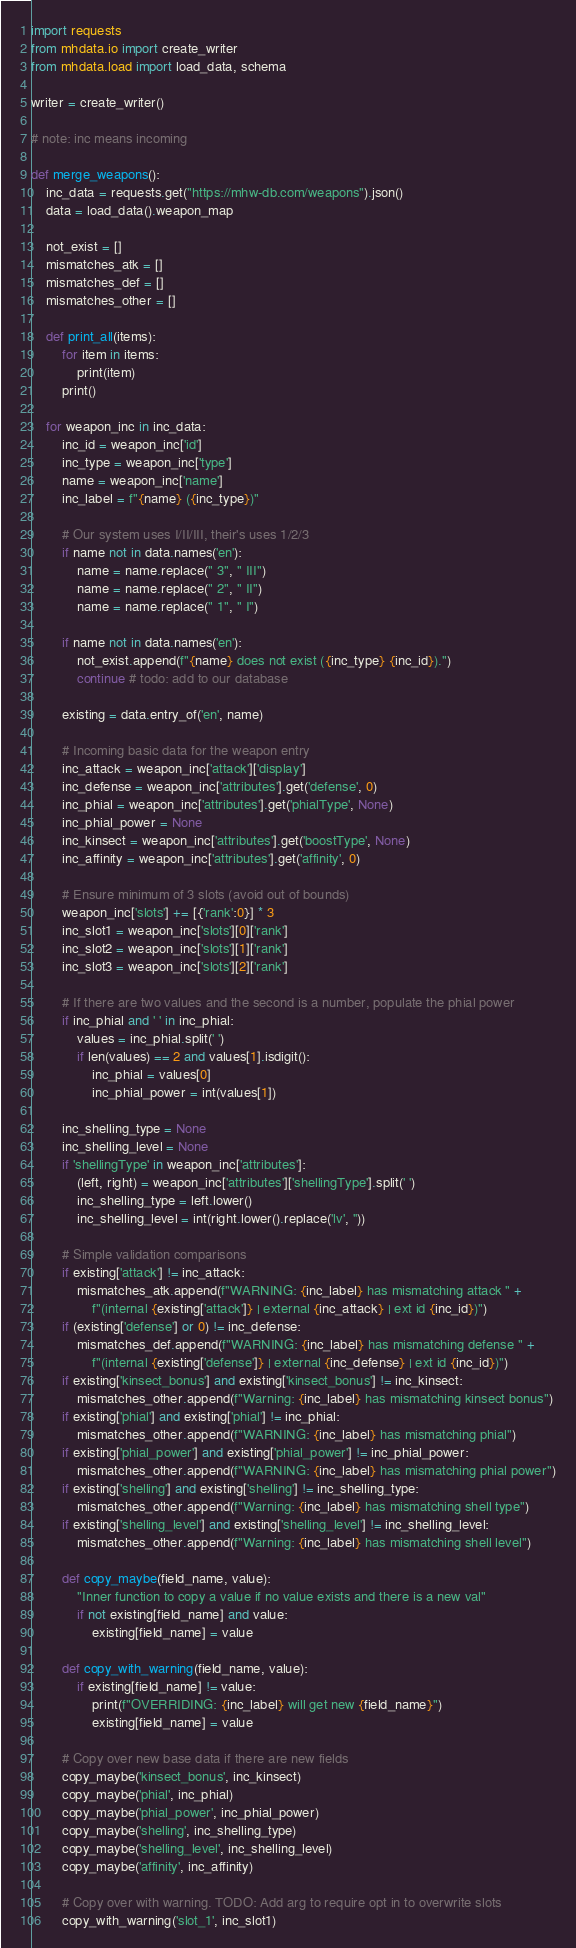Convert code to text. <code><loc_0><loc_0><loc_500><loc_500><_Python_>import requests
from mhdata.io import create_writer
from mhdata.load import load_data, schema

writer = create_writer()

# note: inc means incoming

def merge_weapons():
    inc_data = requests.get("https://mhw-db.com/weapons").json()
    data = load_data().weapon_map

    not_exist = []
    mismatches_atk = []
    mismatches_def = []
    mismatches_other = []

    def print_all(items):
        for item in items:
            print(item)
        print()

    for weapon_inc in inc_data:
        inc_id = weapon_inc['id']
        inc_type = weapon_inc['type']
        name = weapon_inc['name']
        inc_label = f"{name} ({inc_type})"

        # Our system uses I/II/III, their's uses 1/2/3
        if name not in data.names('en'):
            name = name.replace(" 3", " III")
            name = name.replace(" 2", " II")
            name = name.replace(" 1", " I")

        if name not in data.names('en'):
            not_exist.append(f"{name} does not exist ({inc_type} {inc_id}).")
            continue # todo: add to our database

        existing = data.entry_of('en', name)
        
        # Incoming basic data for the weapon entry
        inc_attack = weapon_inc['attack']['display']
        inc_defense = weapon_inc['attributes'].get('defense', 0)
        inc_phial = weapon_inc['attributes'].get('phialType', None)
        inc_phial_power = None
        inc_kinsect = weapon_inc['attributes'].get('boostType', None)
        inc_affinity = weapon_inc['attributes'].get('affinity', 0)

        # Ensure minimum of 3 slots (avoid out of bounds)
        weapon_inc['slots'] += [{'rank':0}] * 3
        inc_slot1 = weapon_inc['slots'][0]['rank']
        inc_slot2 = weapon_inc['slots'][1]['rank']
        inc_slot3 = weapon_inc['slots'][2]['rank']

        # If there are two values and the second is a number, populate the phial power
        if inc_phial and ' ' in inc_phial:
            values = inc_phial.split(' ')
            if len(values) == 2 and values[1].isdigit():
                inc_phial = values[0]
                inc_phial_power = int(values[1])

        inc_shelling_type = None
        inc_shelling_level = None
        if 'shellingType' in weapon_inc['attributes']:
            (left, right) = weapon_inc['attributes']['shellingType'].split(' ')
            inc_shelling_type = left.lower()
            inc_shelling_level = int(right.lower().replace('lv', ''))

        # Simple validation comparisons
        if existing['attack'] != inc_attack:
            mismatches_atk.append(f"WARNING: {inc_label} has mismatching attack " +
                f"(internal {existing['attack']} | external {inc_attack} | ext id {inc_id})")
        if (existing['defense'] or 0) != inc_defense:
            mismatches_def.append(f"WARNING: {inc_label} has mismatching defense " +
                f"(internal {existing['defense']} | external {inc_defense} | ext id {inc_id})")
        if existing['kinsect_bonus'] and existing['kinsect_bonus'] != inc_kinsect:
            mismatches_other.append(f"Warning: {inc_label} has mismatching kinsect bonus")
        if existing['phial'] and existing['phial'] != inc_phial:
            mismatches_other.append(f"WARNING: {inc_label} has mismatching phial")
        if existing['phial_power'] and existing['phial_power'] != inc_phial_power:
            mismatches_other.append(f"WARNING: {inc_label} has mismatching phial power")
        if existing['shelling'] and existing['shelling'] != inc_shelling_type:
            mismatches_other.append(f"Warning: {inc_label} has mismatching shell type")
        if existing['shelling_level'] and existing['shelling_level'] != inc_shelling_level:
            mismatches_other.append(f"Warning: {inc_label} has mismatching shell level")

        def copy_maybe(field_name, value):
            "Inner function to copy a value if no value exists and there is a new val"
            if not existing[field_name] and value:
                existing[field_name] = value

        def copy_with_warning(field_name, value):
            if existing[field_name] != value:
                print(f"OVERRIDING: {inc_label} will get new {field_name}")
                existing[field_name] = value

        # Copy over new base data if there are new fields
        copy_maybe('kinsect_bonus', inc_kinsect)
        copy_maybe('phial', inc_phial)
        copy_maybe('phial_power', inc_phial_power)
        copy_maybe('shelling', inc_shelling_type)
        copy_maybe('shelling_level', inc_shelling_level)
        copy_maybe('affinity', inc_affinity)

        # Copy over with warning. TODO: Add arg to require opt in to overwrite slots
        copy_with_warning('slot_1', inc_slot1)</code> 